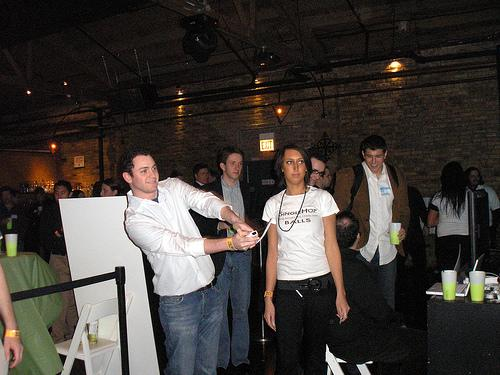Elaborate on the most noticeable attributes of the man and woman in the image. The man is wearing a white shirt, blue jeans, a yellow wristband, and holding a Wii remote. The woman has short hair, a white shirt, and a black necklace. Provide a brief description of the primary activity in the image. A man and a woman are standing in a large room with the man holding a white Wii remote while wearing a yellow wristband. Enumerate some objects that are present in the room along with the people. Green tablecloth, white chair, cups, exit sign, and hanging lights. Characterize the attire and gaming accessories of the man in the image. Man wears white shirt, blue jeans, yellow wristband, and holds a Wii remote. In a few words, mention the principal characters in the image and their relation to gaming. Man and woman, with man holding gaming controller. What are the distinctive features of the setting where the people are located? They are inside a large room with a green tablecloth, white wooden chair, white and yellow cups, and hanging lights.  In a few words, state what the central figures in the picture are involved in. Man and woman in room, man with Wii controller. What is the noticeable behavior of the main male subject in this image? The man is standing and playing a game using a white Wii remote controller. In simple terms, talk about the woman in the image and her appearance. A woman with short hair, wearing a white shirt and a black necklace. Summarize the key features of the image in a single sentence. A man holding a Wii remote and a woman with a necklace stand together in a room with various objects. 